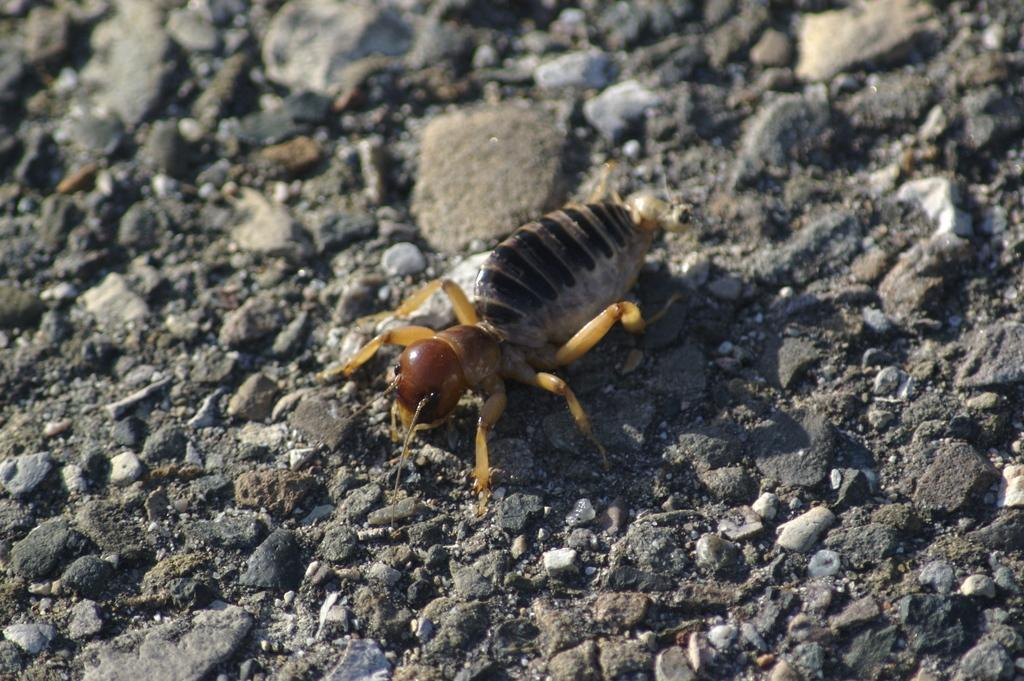What type of objects can be seen in the image? There are stones visible in the image. How many mice are hiding behind the stones in the image? There are no mice present in the image; it only features stones. What type of tin can be seen holding the stones in the image? There is no tin present in the image; it only features stones. 